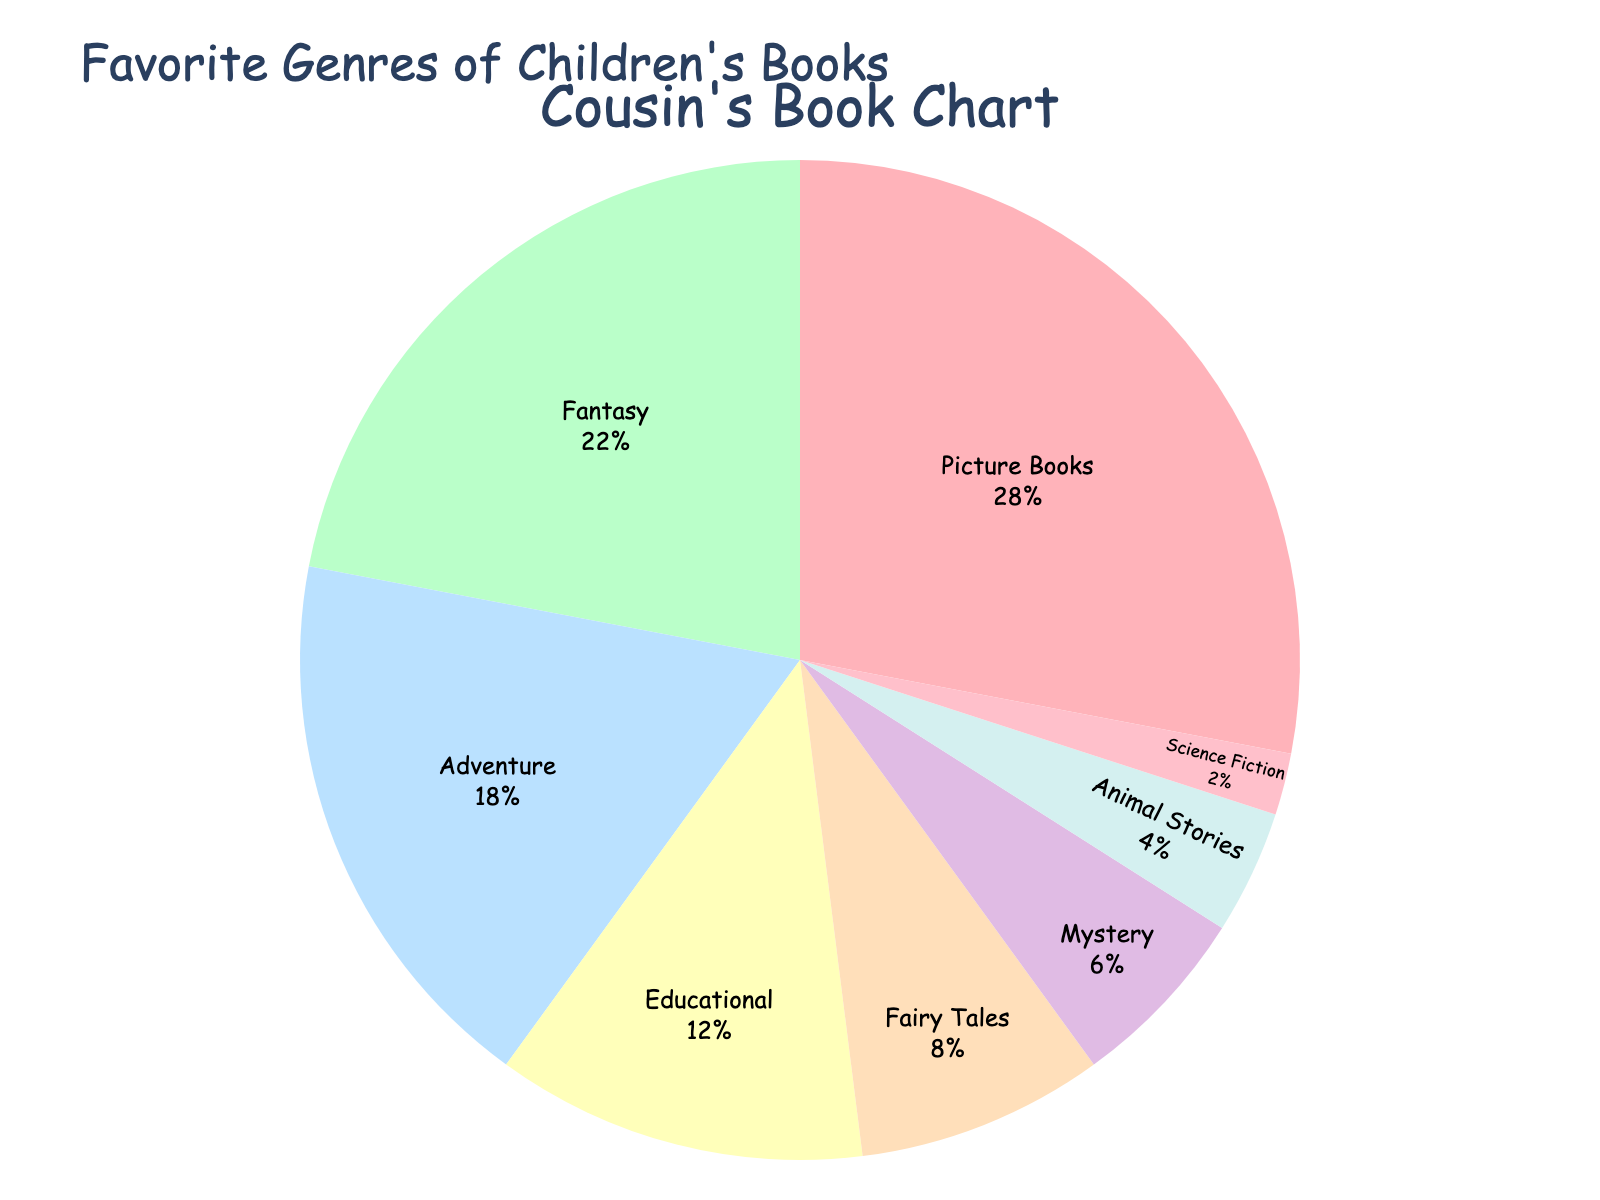Which genre is the most popular? Look for the largest segment in the pie chart. The segment with the highest percentage represents the most popular genre.
Answer: Picture Books What is the combined percentage of Fantasy and Adventure genres? Sum the percentages of both genres: Fantasy (22%) + Adventure (18%).
Answer: 40% How much more popular are Mystery books compared to Animal Stories? Subtract the percentage of Animal Stories from the percentage of Mystery: 6% - 4%.
Answer: 2% Which genre has the smallest percentage? Identify the smallest segment in the pie chart, which corresponds to the genre with the lowest percentage.
Answer: Science Fiction What percentage of children's books are categorized as Educational, Fairy Tales, and Animal Stories combined? Add the percentages of these three genres: Educational (12%) + Fairy Tales (8%) + Animal Stories (4%).
Answer: 24% Are Fantasy books more popular than Fairy Tales? Compare the percentages of Fantasy (22%) and Fairy Tales (8%). Since 22% is greater than 8%, Fantasy books are more popular than Fairy Tales.
Answer: Yes Which genres together make up more than half of the pie chart? Identify the genres that, when summed up, exceed 50%. Add the largest percentages first until the sum exceeds 50%: Picture Books (28%) + Fantasy (22%) = 50%.
Answer: Picture Books, Fantasy By how much does the percentage of Picture Books exceed that of Fantasy? Subtract the percentage of Fantasy from Picture Books: 28% - 22%.
Answer: 6% What is the total percentage covered by genres other than the top two (Picture Books and Fantasy)? Subtract the combined percentage of Picture Books and Fantasy from 100%: 100% - (28% + 22%).
Answer: 50% How does the percentage of Adventure books compare to that of Educational books? Compare the percentages of Adventure (18%) and Educational (12%). Adventure has a higher percentage than Educational.
Answer: Adventure is more popular 